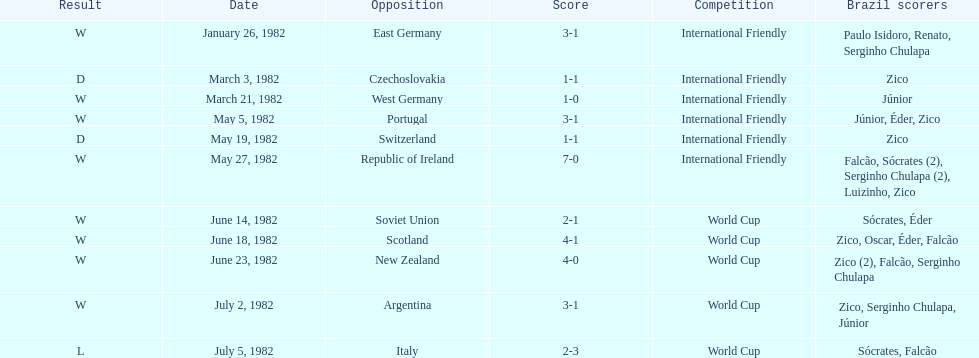Did brazil score more goals against the soviet union or portugal in 1982? Portugal. 